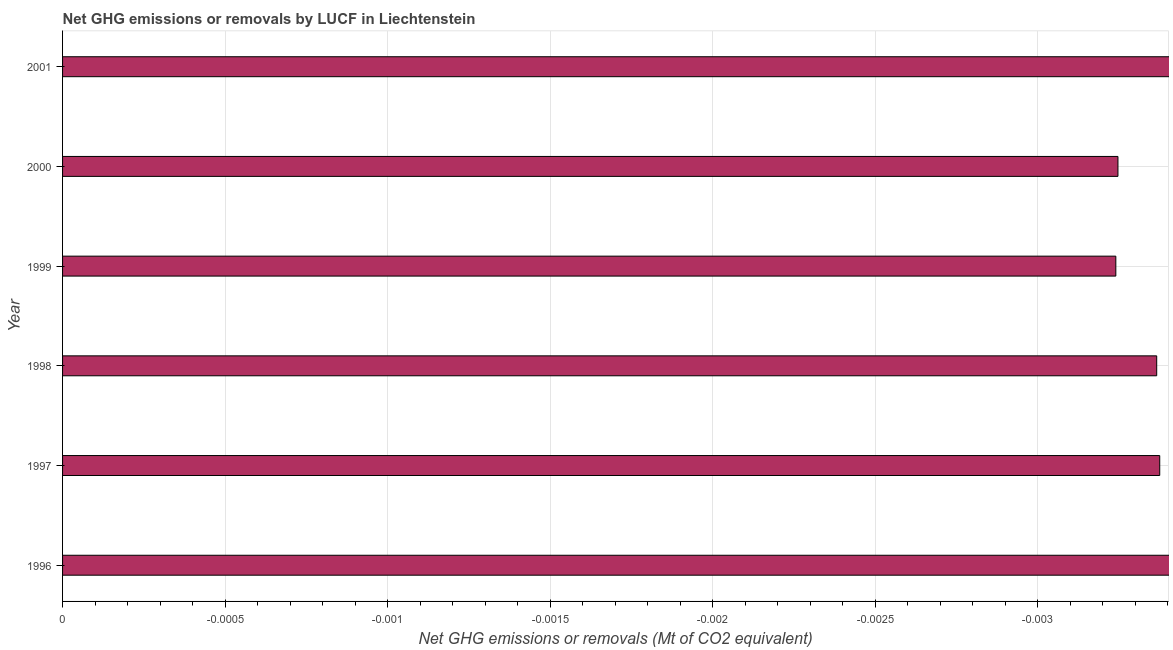What is the title of the graph?
Keep it short and to the point. Net GHG emissions or removals by LUCF in Liechtenstein. What is the label or title of the X-axis?
Your answer should be compact. Net GHG emissions or removals (Mt of CO2 equivalent). Across all years, what is the minimum ghg net emissions or removals?
Keep it short and to the point. 0. What is the sum of the ghg net emissions or removals?
Your answer should be very brief. 0. In how many years, is the ghg net emissions or removals greater than the average ghg net emissions or removals taken over all years?
Provide a succinct answer. 0. What is the difference between two consecutive major ticks on the X-axis?
Your answer should be very brief. 0. What is the Net GHG emissions or removals (Mt of CO2 equivalent) of 1996?
Your response must be concise. 0. What is the Net GHG emissions or removals (Mt of CO2 equivalent) in 1998?
Give a very brief answer. 0. What is the Net GHG emissions or removals (Mt of CO2 equivalent) in 1999?
Offer a very short reply. 0. What is the Net GHG emissions or removals (Mt of CO2 equivalent) in 2000?
Offer a very short reply. 0. 